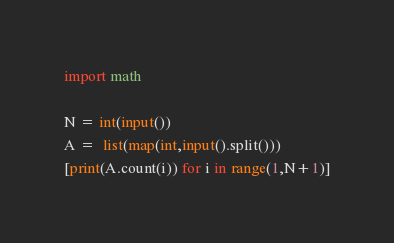<code> <loc_0><loc_0><loc_500><loc_500><_Python_>import math

N = int(input())
A =  list(map(int,input().split()))
[print(A.count(i)) for i in range(1,N+1)]
</code> 